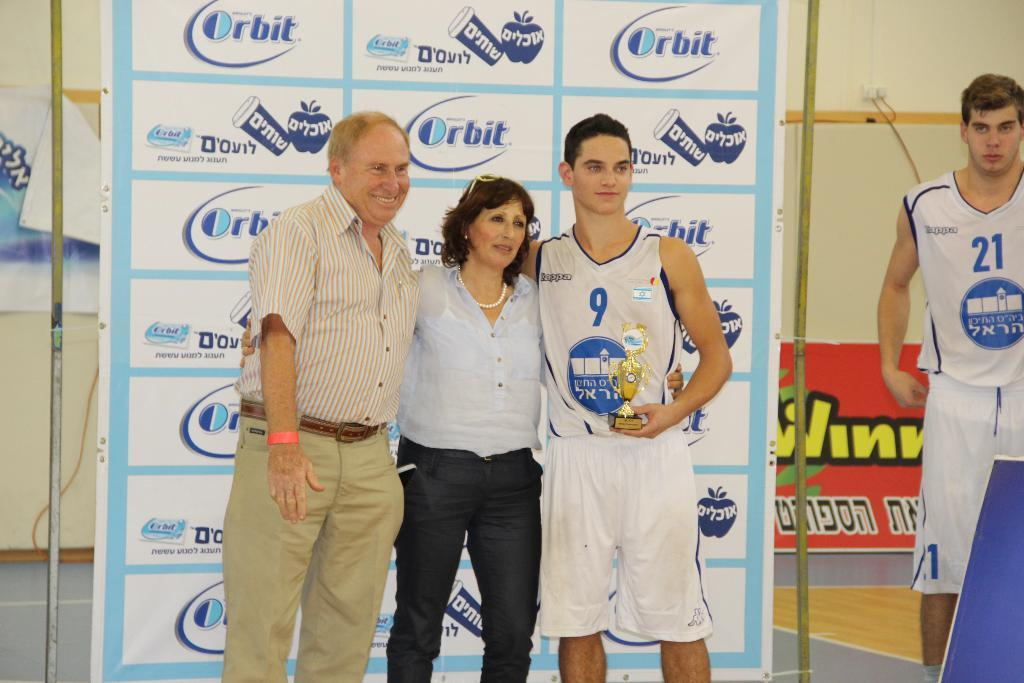<image>
Share a concise interpretation of the image provided. a lady next to a player wearing the number 9 